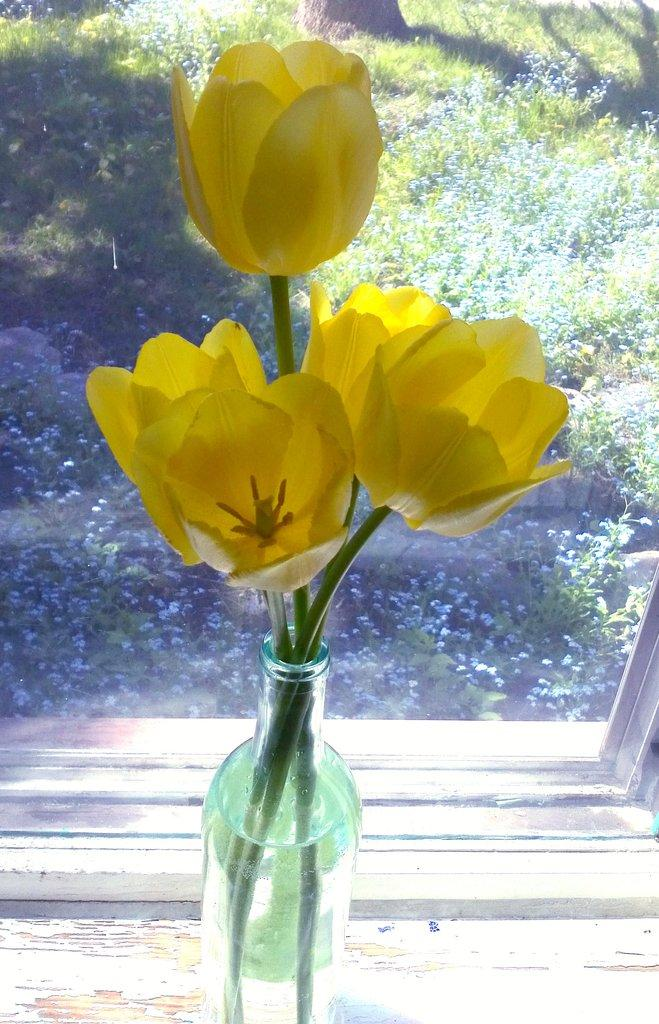What is inside the glass bottle in the image? There is a yellow flower placed inside a glass bottle, and there is also a liquid inside the bottle. What can be seen in the background of the image? The background of the image includes a glass mirror and flowers. What is the condition of the sky in the image? The sky is visible in the background of the image. What type of board is being used to grip the flowers in the image? There is no board or gripping action present in the image; the flowers are simply visible on the other side of the glass mirror. 